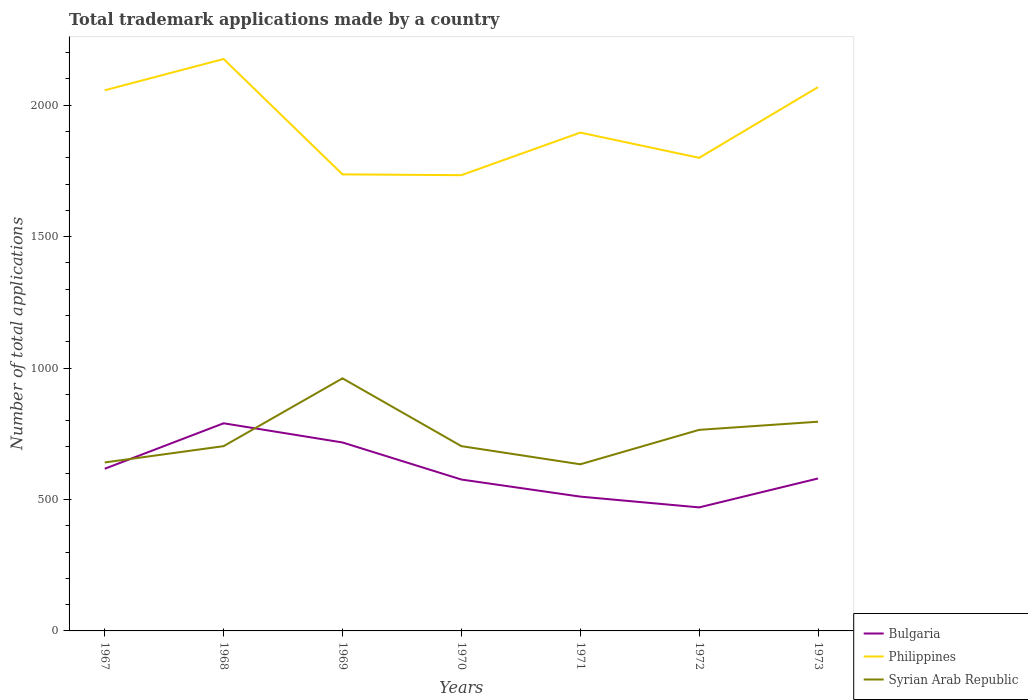How many different coloured lines are there?
Make the answer very short. 3. Is the number of lines equal to the number of legend labels?
Provide a succinct answer. Yes. Across all years, what is the maximum number of applications made by in Philippines?
Make the answer very short. 1734. What is the difference between the highest and the second highest number of applications made by in Syrian Arab Republic?
Provide a short and direct response. 327. How many years are there in the graph?
Provide a succinct answer. 7. Does the graph contain any zero values?
Give a very brief answer. No. Where does the legend appear in the graph?
Provide a short and direct response. Bottom right. What is the title of the graph?
Provide a short and direct response. Total trademark applications made by a country. Does "Australia" appear as one of the legend labels in the graph?
Give a very brief answer. No. What is the label or title of the Y-axis?
Provide a short and direct response. Number of total applications. What is the Number of total applications of Bulgaria in 1967?
Offer a very short reply. 617. What is the Number of total applications in Philippines in 1967?
Provide a short and direct response. 2057. What is the Number of total applications in Syrian Arab Republic in 1967?
Offer a very short reply. 641. What is the Number of total applications of Bulgaria in 1968?
Ensure brevity in your answer.  790. What is the Number of total applications of Philippines in 1968?
Provide a short and direct response. 2176. What is the Number of total applications in Syrian Arab Republic in 1968?
Offer a terse response. 703. What is the Number of total applications of Bulgaria in 1969?
Offer a terse response. 717. What is the Number of total applications of Philippines in 1969?
Your answer should be very brief. 1737. What is the Number of total applications of Syrian Arab Republic in 1969?
Your answer should be very brief. 961. What is the Number of total applications in Bulgaria in 1970?
Give a very brief answer. 576. What is the Number of total applications in Philippines in 1970?
Provide a short and direct response. 1734. What is the Number of total applications in Syrian Arab Republic in 1970?
Make the answer very short. 703. What is the Number of total applications in Bulgaria in 1971?
Ensure brevity in your answer.  511. What is the Number of total applications in Philippines in 1971?
Offer a very short reply. 1896. What is the Number of total applications in Syrian Arab Republic in 1971?
Your response must be concise. 634. What is the Number of total applications of Bulgaria in 1972?
Offer a terse response. 470. What is the Number of total applications of Philippines in 1972?
Give a very brief answer. 1800. What is the Number of total applications of Syrian Arab Republic in 1972?
Ensure brevity in your answer.  765. What is the Number of total applications of Bulgaria in 1973?
Make the answer very short. 580. What is the Number of total applications of Philippines in 1973?
Offer a very short reply. 2069. What is the Number of total applications of Syrian Arab Republic in 1973?
Provide a short and direct response. 796. Across all years, what is the maximum Number of total applications in Bulgaria?
Your answer should be very brief. 790. Across all years, what is the maximum Number of total applications in Philippines?
Keep it short and to the point. 2176. Across all years, what is the maximum Number of total applications of Syrian Arab Republic?
Your answer should be very brief. 961. Across all years, what is the minimum Number of total applications of Bulgaria?
Your answer should be compact. 470. Across all years, what is the minimum Number of total applications of Philippines?
Your answer should be very brief. 1734. Across all years, what is the minimum Number of total applications in Syrian Arab Republic?
Offer a terse response. 634. What is the total Number of total applications of Bulgaria in the graph?
Ensure brevity in your answer.  4261. What is the total Number of total applications of Philippines in the graph?
Provide a short and direct response. 1.35e+04. What is the total Number of total applications in Syrian Arab Republic in the graph?
Provide a succinct answer. 5203. What is the difference between the Number of total applications of Bulgaria in 1967 and that in 1968?
Your answer should be very brief. -173. What is the difference between the Number of total applications in Philippines in 1967 and that in 1968?
Give a very brief answer. -119. What is the difference between the Number of total applications in Syrian Arab Republic in 1967 and that in 1968?
Your answer should be very brief. -62. What is the difference between the Number of total applications of Bulgaria in 1967 and that in 1969?
Give a very brief answer. -100. What is the difference between the Number of total applications of Philippines in 1967 and that in 1969?
Offer a terse response. 320. What is the difference between the Number of total applications of Syrian Arab Republic in 1967 and that in 1969?
Ensure brevity in your answer.  -320. What is the difference between the Number of total applications of Philippines in 1967 and that in 1970?
Provide a succinct answer. 323. What is the difference between the Number of total applications in Syrian Arab Republic in 1967 and that in 1970?
Offer a very short reply. -62. What is the difference between the Number of total applications in Bulgaria in 1967 and that in 1971?
Give a very brief answer. 106. What is the difference between the Number of total applications in Philippines in 1967 and that in 1971?
Make the answer very short. 161. What is the difference between the Number of total applications in Syrian Arab Republic in 1967 and that in 1971?
Make the answer very short. 7. What is the difference between the Number of total applications of Bulgaria in 1967 and that in 1972?
Make the answer very short. 147. What is the difference between the Number of total applications of Philippines in 1967 and that in 1972?
Keep it short and to the point. 257. What is the difference between the Number of total applications of Syrian Arab Republic in 1967 and that in 1972?
Your answer should be very brief. -124. What is the difference between the Number of total applications in Bulgaria in 1967 and that in 1973?
Offer a terse response. 37. What is the difference between the Number of total applications in Syrian Arab Republic in 1967 and that in 1973?
Make the answer very short. -155. What is the difference between the Number of total applications in Bulgaria in 1968 and that in 1969?
Offer a terse response. 73. What is the difference between the Number of total applications in Philippines in 1968 and that in 1969?
Your answer should be very brief. 439. What is the difference between the Number of total applications in Syrian Arab Republic in 1968 and that in 1969?
Your answer should be compact. -258. What is the difference between the Number of total applications of Bulgaria in 1968 and that in 1970?
Your answer should be compact. 214. What is the difference between the Number of total applications in Philippines in 1968 and that in 1970?
Your answer should be compact. 442. What is the difference between the Number of total applications in Bulgaria in 1968 and that in 1971?
Your answer should be compact. 279. What is the difference between the Number of total applications of Philippines in 1968 and that in 1971?
Your answer should be compact. 280. What is the difference between the Number of total applications in Bulgaria in 1968 and that in 1972?
Give a very brief answer. 320. What is the difference between the Number of total applications of Philippines in 1968 and that in 1972?
Keep it short and to the point. 376. What is the difference between the Number of total applications in Syrian Arab Republic in 1968 and that in 1972?
Your answer should be very brief. -62. What is the difference between the Number of total applications of Bulgaria in 1968 and that in 1973?
Ensure brevity in your answer.  210. What is the difference between the Number of total applications of Philippines in 1968 and that in 1973?
Provide a short and direct response. 107. What is the difference between the Number of total applications in Syrian Arab Republic in 1968 and that in 1973?
Provide a succinct answer. -93. What is the difference between the Number of total applications of Bulgaria in 1969 and that in 1970?
Make the answer very short. 141. What is the difference between the Number of total applications of Philippines in 1969 and that in 1970?
Ensure brevity in your answer.  3. What is the difference between the Number of total applications in Syrian Arab Republic in 1969 and that in 1970?
Your response must be concise. 258. What is the difference between the Number of total applications in Bulgaria in 1969 and that in 1971?
Provide a succinct answer. 206. What is the difference between the Number of total applications of Philippines in 1969 and that in 1971?
Your response must be concise. -159. What is the difference between the Number of total applications of Syrian Arab Republic in 1969 and that in 1971?
Give a very brief answer. 327. What is the difference between the Number of total applications in Bulgaria in 1969 and that in 1972?
Make the answer very short. 247. What is the difference between the Number of total applications in Philippines in 1969 and that in 1972?
Ensure brevity in your answer.  -63. What is the difference between the Number of total applications of Syrian Arab Republic in 1969 and that in 1972?
Offer a very short reply. 196. What is the difference between the Number of total applications of Bulgaria in 1969 and that in 1973?
Offer a terse response. 137. What is the difference between the Number of total applications of Philippines in 1969 and that in 1973?
Keep it short and to the point. -332. What is the difference between the Number of total applications of Syrian Arab Republic in 1969 and that in 1973?
Keep it short and to the point. 165. What is the difference between the Number of total applications of Philippines in 1970 and that in 1971?
Provide a succinct answer. -162. What is the difference between the Number of total applications in Bulgaria in 1970 and that in 1972?
Offer a very short reply. 106. What is the difference between the Number of total applications in Philippines in 1970 and that in 1972?
Ensure brevity in your answer.  -66. What is the difference between the Number of total applications in Syrian Arab Republic in 1970 and that in 1972?
Offer a very short reply. -62. What is the difference between the Number of total applications of Bulgaria in 1970 and that in 1973?
Ensure brevity in your answer.  -4. What is the difference between the Number of total applications of Philippines in 1970 and that in 1973?
Provide a short and direct response. -335. What is the difference between the Number of total applications of Syrian Arab Republic in 1970 and that in 1973?
Offer a terse response. -93. What is the difference between the Number of total applications of Bulgaria in 1971 and that in 1972?
Give a very brief answer. 41. What is the difference between the Number of total applications in Philippines in 1971 and that in 1972?
Ensure brevity in your answer.  96. What is the difference between the Number of total applications in Syrian Arab Republic in 1971 and that in 1972?
Keep it short and to the point. -131. What is the difference between the Number of total applications in Bulgaria in 1971 and that in 1973?
Make the answer very short. -69. What is the difference between the Number of total applications in Philippines in 1971 and that in 1973?
Your answer should be very brief. -173. What is the difference between the Number of total applications in Syrian Arab Republic in 1971 and that in 1973?
Offer a very short reply. -162. What is the difference between the Number of total applications of Bulgaria in 1972 and that in 1973?
Provide a succinct answer. -110. What is the difference between the Number of total applications of Philippines in 1972 and that in 1973?
Your answer should be compact. -269. What is the difference between the Number of total applications of Syrian Arab Republic in 1972 and that in 1973?
Give a very brief answer. -31. What is the difference between the Number of total applications in Bulgaria in 1967 and the Number of total applications in Philippines in 1968?
Ensure brevity in your answer.  -1559. What is the difference between the Number of total applications in Bulgaria in 1967 and the Number of total applications in Syrian Arab Republic in 1968?
Keep it short and to the point. -86. What is the difference between the Number of total applications in Philippines in 1967 and the Number of total applications in Syrian Arab Republic in 1968?
Ensure brevity in your answer.  1354. What is the difference between the Number of total applications of Bulgaria in 1967 and the Number of total applications of Philippines in 1969?
Keep it short and to the point. -1120. What is the difference between the Number of total applications of Bulgaria in 1967 and the Number of total applications of Syrian Arab Republic in 1969?
Offer a very short reply. -344. What is the difference between the Number of total applications in Philippines in 1967 and the Number of total applications in Syrian Arab Republic in 1969?
Your answer should be compact. 1096. What is the difference between the Number of total applications of Bulgaria in 1967 and the Number of total applications of Philippines in 1970?
Provide a short and direct response. -1117. What is the difference between the Number of total applications in Bulgaria in 1967 and the Number of total applications in Syrian Arab Republic in 1970?
Your answer should be very brief. -86. What is the difference between the Number of total applications of Philippines in 1967 and the Number of total applications of Syrian Arab Republic in 1970?
Offer a very short reply. 1354. What is the difference between the Number of total applications of Bulgaria in 1967 and the Number of total applications of Philippines in 1971?
Offer a terse response. -1279. What is the difference between the Number of total applications in Philippines in 1967 and the Number of total applications in Syrian Arab Republic in 1971?
Ensure brevity in your answer.  1423. What is the difference between the Number of total applications in Bulgaria in 1967 and the Number of total applications in Philippines in 1972?
Keep it short and to the point. -1183. What is the difference between the Number of total applications of Bulgaria in 1967 and the Number of total applications of Syrian Arab Republic in 1972?
Keep it short and to the point. -148. What is the difference between the Number of total applications in Philippines in 1967 and the Number of total applications in Syrian Arab Republic in 1972?
Your answer should be very brief. 1292. What is the difference between the Number of total applications of Bulgaria in 1967 and the Number of total applications of Philippines in 1973?
Ensure brevity in your answer.  -1452. What is the difference between the Number of total applications in Bulgaria in 1967 and the Number of total applications in Syrian Arab Republic in 1973?
Provide a short and direct response. -179. What is the difference between the Number of total applications of Philippines in 1967 and the Number of total applications of Syrian Arab Republic in 1973?
Offer a very short reply. 1261. What is the difference between the Number of total applications in Bulgaria in 1968 and the Number of total applications in Philippines in 1969?
Keep it short and to the point. -947. What is the difference between the Number of total applications in Bulgaria in 1968 and the Number of total applications in Syrian Arab Republic in 1969?
Ensure brevity in your answer.  -171. What is the difference between the Number of total applications in Philippines in 1968 and the Number of total applications in Syrian Arab Republic in 1969?
Offer a very short reply. 1215. What is the difference between the Number of total applications of Bulgaria in 1968 and the Number of total applications of Philippines in 1970?
Your answer should be compact. -944. What is the difference between the Number of total applications of Philippines in 1968 and the Number of total applications of Syrian Arab Republic in 1970?
Your answer should be compact. 1473. What is the difference between the Number of total applications of Bulgaria in 1968 and the Number of total applications of Philippines in 1971?
Offer a terse response. -1106. What is the difference between the Number of total applications in Bulgaria in 1968 and the Number of total applications in Syrian Arab Republic in 1971?
Keep it short and to the point. 156. What is the difference between the Number of total applications in Philippines in 1968 and the Number of total applications in Syrian Arab Republic in 1971?
Offer a very short reply. 1542. What is the difference between the Number of total applications in Bulgaria in 1968 and the Number of total applications in Philippines in 1972?
Keep it short and to the point. -1010. What is the difference between the Number of total applications of Philippines in 1968 and the Number of total applications of Syrian Arab Republic in 1972?
Keep it short and to the point. 1411. What is the difference between the Number of total applications of Bulgaria in 1968 and the Number of total applications of Philippines in 1973?
Your response must be concise. -1279. What is the difference between the Number of total applications of Philippines in 1968 and the Number of total applications of Syrian Arab Republic in 1973?
Your response must be concise. 1380. What is the difference between the Number of total applications of Bulgaria in 1969 and the Number of total applications of Philippines in 1970?
Your answer should be very brief. -1017. What is the difference between the Number of total applications in Bulgaria in 1969 and the Number of total applications in Syrian Arab Republic in 1970?
Offer a terse response. 14. What is the difference between the Number of total applications of Philippines in 1969 and the Number of total applications of Syrian Arab Republic in 1970?
Your response must be concise. 1034. What is the difference between the Number of total applications of Bulgaria in 1969 and the Number of total applications of Philippines in 1971?
Make the answer very short. -1179. What is the difference between the Number of total applications of Bulgaria in 1969 and the Number of total applications of Syrian Arab Republic in 1971?
Your answer should be compact. 83. What is the difference between the Number of total applications in Philippines in 1969 and the Number of total applications in Syrian Arab Republic in 1971?
Offer a very short reply. 1103. What is the difference between the Number of total applications in Bulgaria in 1969 and the Number of total applications in Philippines in 1972?
Your answer should be compact. -1083. What is the difference between the Number of total applications of Bulgaria in 1969 and the Number of total applications of Syrian Arab Republic in 1972?
Ensure brevity in your answer.  -48. What is the difference between the Number of total applications in Philippines in 1969 and the Number of total applications in Syrian Arab Republic in 1972?
Provide a short and direct response. 972. What is the difference between the Number of total applications in Bulgaria in 1969 and the Number of total applications in Philippines in 1973?
Provide a short and direct response. -1352. What is the difference between the Number of total applications of Bulgaria in 1969 and the Number of total applications of Syrian Arab Republic in 1973?
Your answer should be compact. -79. What is the difference between the Number of total applications of Philippines in 1969 and the Number of total applications of Syrian Arab Republic in 1973?
Your answer should be compact. 941. What is the difference between the Number of total applications in Bulgaria in 1970 and the Number of total applications in Philippines in 1971?
Your answer should be very brief. -1320. What is the difference between the Number of total applications of Bulgaria in 1970 and the Number of total applications of Syrian Arab Republic in 1971?
Give a very brief answer. -58. What is the difference between the Number of total applications of Philippines in 1970 and the Number of total applications of Syrian Arab Republic in 1971?
Provide a short and direct response. 1100. What is the difference between the Number of total applications in Bulgaria in 1970 and the Number of total applications in Philippines in 1972?
Keep it short and to the point. -1224. What is the difference between the Number of total applications of Bulgaria in 1970 and the Number of total applications of Syrian Arab Republic in 1972?
Offer a very short reply. -189. What is the difference between the Number of total applications of Philippines in 1970 and the Number of total applications of Syrian Arab Republic in 1972?
Make the answer very short. 969. What is the difference between the Number of total applications in Bulgaria in 1970 and the Number of total applications in Philippines in 1973?
Your answer should be compact. -1493. What is the difference between the Number of total applications in Bulgaria in 1970 and the Number of total applications in Syrian Arab Republic in 1973?
Provide a succinct answer. -220. What is the difference between the Number of total applications in Philippines in 1970 and the Number of total applications in Syrian Arab Republic in 1973?
Provide a short and direct response. 938. What is the difference between the Number of total applications in Bulgaria in 1971 and the Number of total applications in Philippines in 1972?
Offer a very short reply. -1289. What is the difference between the Number of total applications of Bulgaria in 1971 and the Number of total applications of Syrian Arab Republic in 1972?
Keep it short and to the point. -254. What is the difference between the Number of total applications of Philippines in 1971 and the Number of total applications of Syrian Arab Republic in 1972?
Offer a terse response. 1131. What is the difference between the Number of total applications in Bulgaria in 1971 and the Number of total applications in Philippines in 1973?
Your answer should be very brief. -1558. What is the difference between the Number of total applications in Bulgaria in 1971 and the Number of total applications in Syrian Arab Republic in 1973?
Make the answer very short. -285. What is the difference between the Number of total applications in Philippines in 1971 and the Number of total applications in Syrian Arab Republic in 1973?
Offer a very short reply. 1100. What is the difference between the Number of total applications of Bulgaria in 1972 and the Number of total applications of Philippines in 1973?
Ensure brevity in your answer.  -1599. What is the difference between the Number of total applications in Bulgaria in 1972 and the Number of total applications in Syrian Arab Republic in 1973?
Offer a very short reply. -326. What is the difference between the Number of total applications of Philippines in 1972 and the Number of total applications of Syrian Arab Republic in 1973?
Give a very brief answer. 1004. What is the average Number of total applications of Bulgaria per year?
Offer a very short reply. 608.71. What is the average Number of total applications of Philippines per year?
Offer a very short reply. 1924.14. What is the average Number of total applications of Syrian Arab Republic per year?
Provide a short and direct response. 743.29. In the year 1967, what is the difference between the Number of total applications of Bulgaria and Number of total applications of Philippines?
Provide a succinct answer. -1440. In the year 1967, what is the difference between the Number of total applications of Bulgaria and Number of total applications of Syrian Arab Republic?
Make the answer very short. -24. In the year 1967, what is the difference between the Number of total applications of Philippines and Number of total applications of Syrian Arab Republic?
Provide a short and direct response. 1416. In the year 1968, what is the difference between the Number of total applications in Bulgaria and Number of total applications in Philippines?
Provide a short and direct response. -1386. In the year 1968, what is the difference between the Number of total applications of Philippines and Number of total applications of Syrian Arab Republic?
Ensure brevity in your answer.  1473. In the year 1969, what is the difference between the Number of total applications in Bulgaria and Number of total applications in Philippines?
Offer a very short reply. -1020. In the year 1969, what is the difference between the Number of total applications of Bulgaria and Number of total applications of Syrian Arab Republic?
Give a very brief answer. -244. In the year 1969, what is the difference between the Number of total applications of Philippines and Number of total applications of Syrian Arab Republic?
Ensure brevity in your answer.  776. In the year 1970, what is the difference between the Number of total applications of Bulgaria and Number of total applications of Philippines?
Offer a terse response. -1158. In the year 1970, what is the difference between the Number of total applications in Bulgaria and Number of total applications in Syrian Arab Republic?
Keep it short and to the point. -127. In the year 1970, what is the difference between the Number of total applications in Philippines and Number of total applications in Syrian Arab Republic?
Keep it short and to the point. 1031. In the year 1971, what is the difference between the Number of total applications in Bulgaria and Number of total applications in Philippines?
Keep it short and to the point. -1385. In the year 1971, what is the difference between the Number of total applications of Bulgaria and Number of total applications of Syrian Arab Republic?
Make the answer very short. -123. In the year 1971, what is the difference between the Number of total applications in Philippines and Number of total applications in Syrian Arab Republic?
Your response must be concise. 1262. In the year 1972, what is the difference between the Number of total applications of Bulgaria and Number of total applications of Philippines?
Your answer should be compact. -1330. In the year 1972, what is the difference between the Number of total applications of Bulgaria and Number of total applications of Syrian Arab Republic?
Your answer should be compact. -295. In the year 1972, what is the difference between the Number of total applications of Philippines and Number of total applications of Syrian Arab Republic?
Make the answer very short. 1035. In the year 1973, what is the difference between the Number of total applications of Bulgaria and Number of total applications of Philippines?
Your answer should be very brief. -1489. In the year 1973, what is the difference between the Number of total applications of Bulgaria and Number of total applications of Syrian Arab Republic?
Your response must be concise. -216. In the year 1973, what is the difference between the Number of total applications of Philippines and Number of total applications of Syrian Arab Republic?
Make the answer very short. 1273. What is the ratio of the Number of total applications of Bulgaria in 1967 to that in 1968?
Provide a succinct answer. 0.78. What is the ratio of the Number of total applications in Philippines in 1967 to that in 1968?
Make the answer very short. 0.95. What is the ratio of the Number of total applications in Syrian Arab Republic in 1967 to that in 1968?
Give a very brief answer. 0.91. What is the ratio of the Number of total applications of Bulgaria in 1967 to that in 1969?
Your answer should be compact. 0.86. What is the ratio of the Number of total applications in Philippines in 1967 to that in 1969?
Your response must be concise. 1.18. What is the ratio of the Number of total applications of Syrian Arab Republic in 1967 to that in 1969?
Your answer should be very brief. 0.67. What is the ratio of the Number of total applications of Bulgaria in 1967 to that in 1970?
Your response must be concise. 1.07. What is the ratio of the Number of total applications of Philippines in 1967 to that in 1970?
Give a very brief answer. 1.19. What is the ratio of the Number of total applications in Syrian Arab Republic in 1967 to that in 1970?
Your response must be concise. 0.91. What is the ratio of the Number of total applications in Bulgaria in 1967 to that in 1971?
Give a very brief answer. 1.21. What is the ratio of the Number of total applications of Philippines in 1967 to that in 1971?
Your answer should be compact. 1.08. What is the ratio of the Number of total applications of Syrian Arab Republic in 1967 to that in 1971?
Your answer should be very brief. 1.01. What is the ratio of the Number of total applications of Bulgaria in 1967 to that in 1972?
Your answer should be compact. 1.31. What is the ratio of the Number of total applications in Philippines in 1967 to that in 1972?
Ensure brevity in your answer.  1.14. What is the ratio of the Number of total applications of Syrian Arab Republic in 1967 to that in 1972?
Make the answer very short. 0.84. What is the ratio of the Number of total applications in Bulgaria in 1967 to that in 1973?
Provide a short and direct response. 1.06. What is the ratio of the Number of total applications in Syrian Arab Republic in 1967 to that in 1973?
Provide a succinct answer. 0.81. What is the ratio of the Number of total applications of Bulgaria in 1968 to that in 1969?
Provide a short and direct response. 1.1. What is the ratio of the Number of total applications of Philippines in 1968 to that in 1969?
Offer a terse response. 1.25. What is the ratio of the Number of total applications of Syrian Arab Republic in 1968 to that in 1969?
Provide a short and direct response. 0.73. What is the ratio of the Number of total applications in Bulgaria in 1968 to that in 1970?
Provide a succinct answer. 1.37. What is the ratio of the Number of total applications of Philippines in 1968 to that in 1970?
Your answer should be compact. 1.25. What is the ratio of the Number of total applications in Bulgaria in 1968 to that in 1971?
Make the answer very short. 1.55. What is the ratio of the Number of total applications in Philippines in 1968 to that in 1971?
Keep it short and to the point. 1.15. What is the ratio of the Number of total applications in Syrian Arab Republic in 1968 to that in 1971?
Make the answer very short. 1.11. What is the ratio of the Number of total applications of Bulgaria in 1968 to that in 1972?
Your answer should be compact. 1.68. What is the ratio of the Number of total applications of Philippines in 1968 to that in 1972?
Keep it short and to the point. 1.21. What is the ratio of the Number of total applications of Syrian Arab Republic in 1968 to that in 1972?
Provide a succinct answer. 0.92. What is the ratio of the Number of total applications in Bulgaria in 1968 to that in 1973?
Keep it short and to the point. 1.36. What is the ratio of the Number of total applications of Philippines in 1968 to that in 1973?
Give a very brief answer. 1.05. What is the ratio of the Number of total applications in Syrian Arab Republic in 1968 to that in 1973?
Offer a very short reply. 0.88. What is the ratio of the Number of total applications of Bulgaria in 1969 to that in 1970?
Offer a very short reply. 1.24. What is the ratio of the Number of total applications of Syrian Arab Republic in 1969 to that in 1970?
Your response must be concise. 1.37. What is the ratio of the Number of total applications in Bulgaria in 1969 to that in 1971?
Your response must be concise. 1.4. What is the ratio of the Number of total applications in Philippines in 1969 to that in 1971?
Give a very brief answer. 0.92. What is the ratio of the Number of total applications in Syrian Arab Republic in 1969 to that in 1971?
Your answer should be compact. 1.52. What is the ratio of the Number of total applications of Bulgaria in 1969 to that in 1972?
Ensure brevity in your answer.  1.53. What is the ratio of the Number of total applications in Syrian Arab Republic in 1969 to that in 1972?
Offer a very short reply. 1.26. What is the ratio of the Number of total applications in Bulgaria in 1969 to that in 1973?
Provide a short and direct response. 1.24. What is the ratio of the Number of total applications of Philippines in 1969 to that in 1973?
Provide a succinct answer. 0.84. What is the ratio of the Number of total applications in Syrian Arab Republic in 1969 to that in 1973?
Offer a very short reply. 1.21. What is the ratio of the Number of total applications of Bulgaria in 1970 to that in 1971?
Your answer should be compact. 1.13. What is the ratio of the Number of total applications in Philippines in 1970 to that in 1971?
Ensure brevity in your answer.  0.91. What is the ratio of the Number of total applications of Syrian Arab Republic in 1970 to that in 1971?
Keep it short and to the point. 1.11. What is the ratio of the Number of total applications of Bulgaria in 1970 to that in 1972?
Provide a short and direct response. 1.23. What is the ratio of the Number of total applications in Philippines in 1970 to that in 1972?
Your answer should be very brief. 0.96. What is the ratio of the Number of total applications of Syrian Arab Republic in 1970 to that in 1972?
Provide a succinct answer. 0.92. What is the ratio of the Number of total applications in Philippines in 1970 to that in 1973?
Provide a succinct answer. 0.84. What is the ratio of the Number of total applications in Syrian Arab Republic in 1970 to that in 1973?
Your answer should be very brief. 0.88. What is the ratio of the Number of total applications in Bulgaria in 1971 to that in 1972?
Offer a very short reply. 1.09. What is the ratio of the Number of total applications of Philippines in 1971 to that in 1972?
Provide a short and direct response. 1.05. What is the ratio of the Number of total applications in Syrian Arab Republic in 1971 to that in 1972?
Ensure brevity in your answer.  0.83. What is the ratio of the Number of total applications in Bulgaria in 1971 to that in 1973?
Your response must be concise. 0.88. What is the ratio of the Number of total applications in Philippines in 1971 to that in 1973?
Make the answer very short. 0.92. What is the ratio of the Number of total applications of Syrian Arab Republic in 1971 to that in 1973?
Your answer should be compact. 0.8. What is the ratio of the Number of total applications in Bulgaria in 1972 to that in 1973?
Provide a short and direct response. 0.81. What is the ratio of the Number of total applications in Philippines in 1972 to that in 1973?
Give a very brief answer. 0.87. What is the ratio of the Number of total applications in Syrian Arab Republic in 1972 to that in 1973?
Make the answer very short. 0.96. What is the difference between the highest and the second highest Number of total applications of Philippines?
Give a very brief answer. 107. What is the difference between the highest and the second highest Number of total applications of Syrian Arab Republic?
Ensure brevity in your answer.  165. What is the difference between the highest and the lowest Number of total applications of Bulgaria?
Offer a terse response. 320. What is the difference between the highest and the lowest Number of total applications in Philippines?
Give a very brief answer. 442. What is the difference between the highest and the lowest Number of total applications of Syrian Arab Republic?
Provide a succinct answer. 327. 